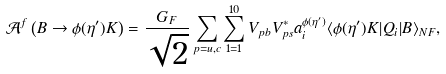<formula> <loc_0><loc_0><loc_500><loc_500>\mathcal { A } ^ { f } \left ( B \to \phi ( \eta ^ { \prime } ) K \right ) = \frac { G _ { F } } { \sqrt { 2 } } \sum _ { p = u , c } \sum _ { 1 = 1 } ^ { 1 0 } V _ { p b } V _ { p s } ^ { * } a _ { i } ^ { \phi ( \eta ^ { \prime } ) } \langle \phi ( \eta ^ { \prime } ) K | Q _ { i } | B \rangle _ { N F } ,</formula> 